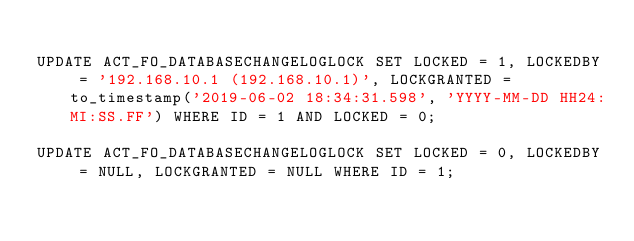<code> <loc_0><loc_0><loc_500><loc_500><_SQL_>
UPDATE ACT_FO_DATABASECHANGELOGLOCK SET LOCKED = 1, LOCKEDBY = '192.168.10.1 (192.168.10.1)', LOCKGRANTED = to_timestamp('2019-06-02 18:34:31.598', 'YYYY-MM-DD HH24:MI:SS.FF') WHERE ID = 1 AND LOCKED = 0;

UPDATE ACT_FO_DATABASECHANGELOGLOCK SET LOCKED = 0, LOCKEDBY = NULL, LOCKGRANTED = NULL WHERE ID = 1;

</code> 